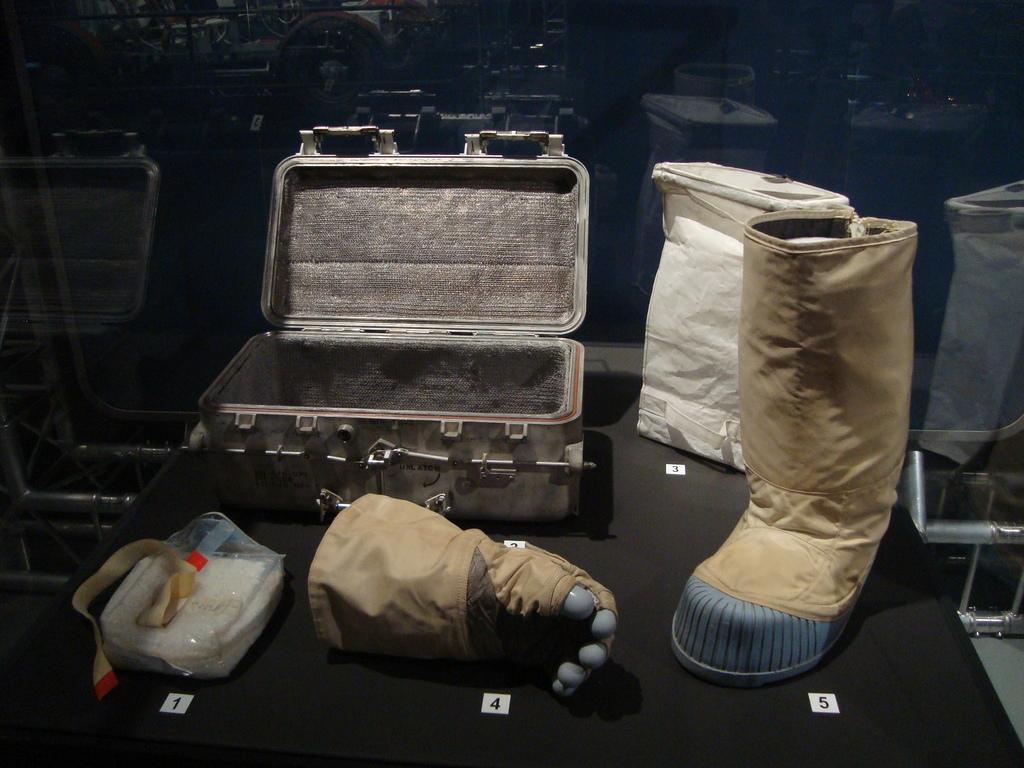In one or two sentences, can you explain what this image depicts? In this picture there is a suitcase, glove, plastic cover, gumboot and other objects. 